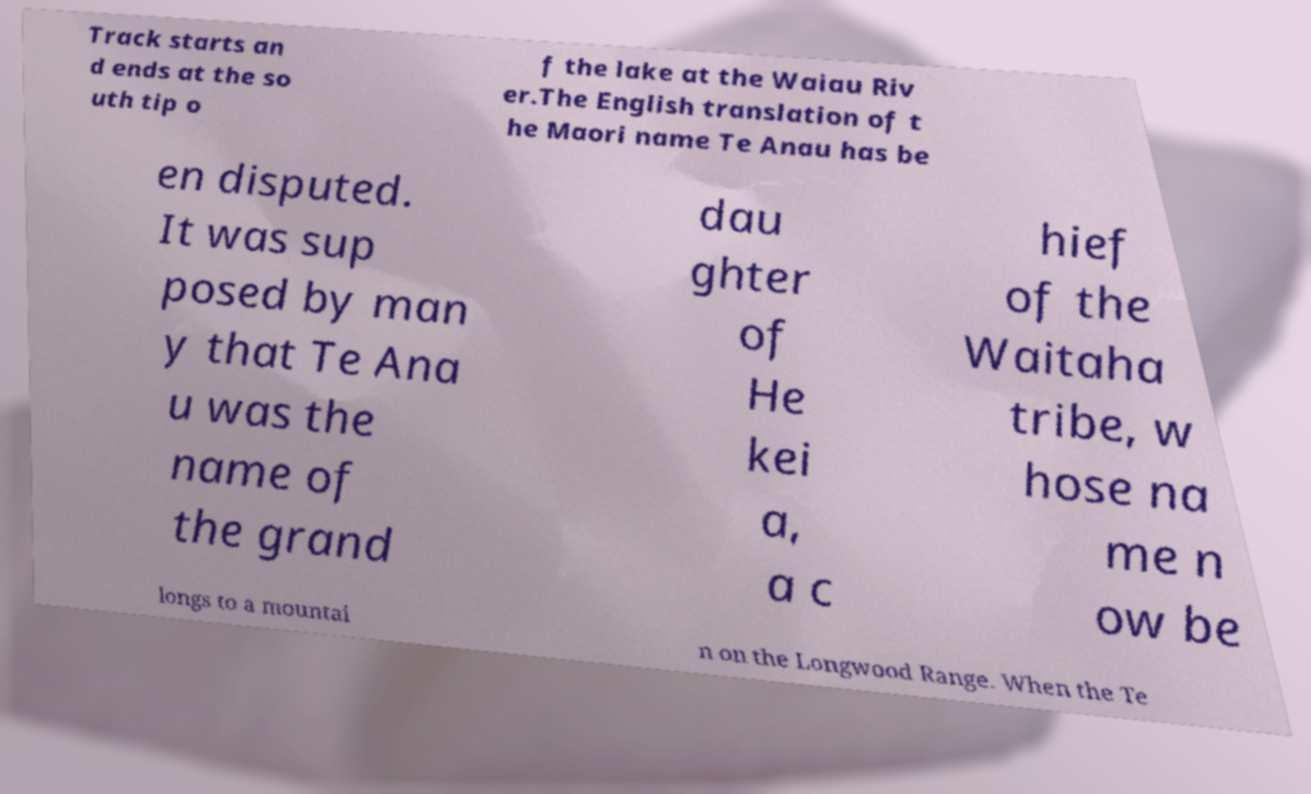Please read and relay the text visible in this image. What does it say? Track starts an d ends at the so uth tip o f the lake at the Waiau Riv er.The English translation of t he Maori name Te Anau has be en disputed. It was sup posed by man y that Te Ana u was the name of the grand dau ghter of He kei a, a c hief of the Waitaha tribe, w hose na me n ow be longs to a mountai n on the Longwood Range. When the Te 